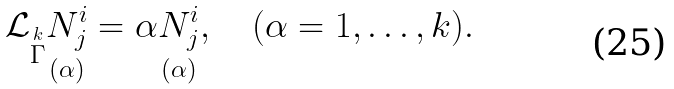Convert formula to latex. <formula><loc_0><loc_0><loc_500><loc_500>\mathcal { L } _ { \stackrel { k } { \Gamma } } \underset { ( \alpha ) } { N _ { j } ^ { i } } = \alpha \underset { ( \alpha ) } { N _ { j } ^ { i } } , \quad ( \alpha = 1 , \dots , k ) .</formula> 